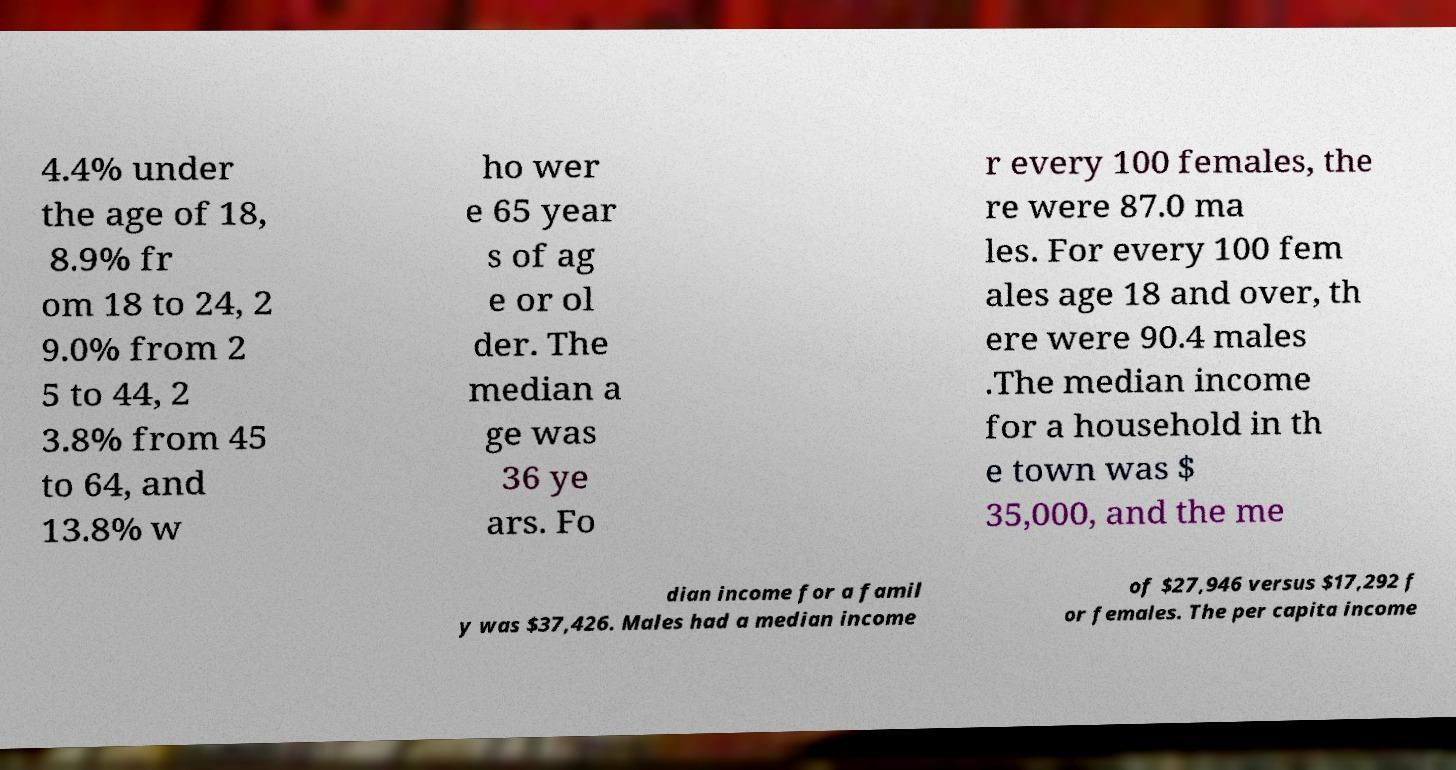Can you accurately transcribe the text from the provided image for me? 4.4% under the age of 18, 8.9% fr om 18 to 24, 2 9.0% from 2 5 to 44, 2 3.8% from 45 to 64, and 13.8% w ho wer e 65 year s of ag e or ol der. The median a ge was 36 ye ars. Fo r every 100 females, the re were 87.0 ma les. For every 100 fem ales age 18 and over, th ere were 90.4 males .The median income for a household in th e town was $ 35,000, and the me dian income for a famil y was $37,426. Males had a median income of $27,946 versus $17,292 f or females. The per capita income 